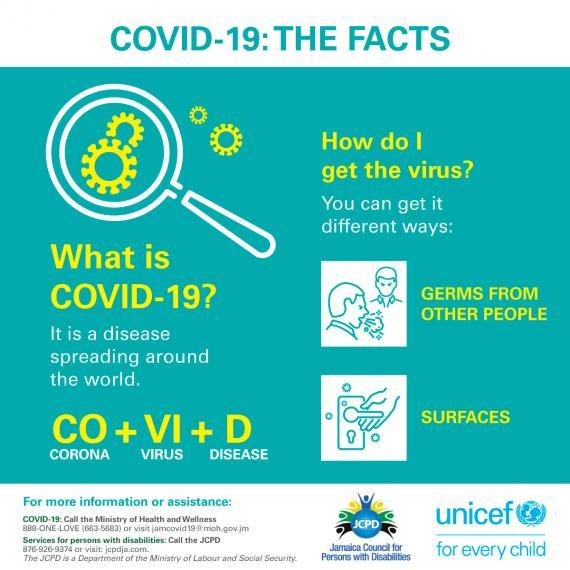Specify some key components in this picture. There are three facts about COVID-19 listed in the infographic. There are two ways to potentially contract COVID-19, which is the coronavirus that causes COVID-19. These ways include coming into close contact with an infected person or touching a surface or object that has the virus on it and then touching your mouth, nose, or eyes. It is important to take precautions to prevent the spread of COVID-19, such as practicing good hygiene, avoiding close contact with sick people, and staying home if you are feeling sick. The first two letters of COVID-19 stand for "COrona VIrus Disease". The COVID-19 virus can be transmitted through direct contact with an infected person, as well as indirect contact with contaminated surfaces or objects that have been in close proximity to an infected individual. It is possible to contract COVID-19 through surfaces, according to the second method of infection. 